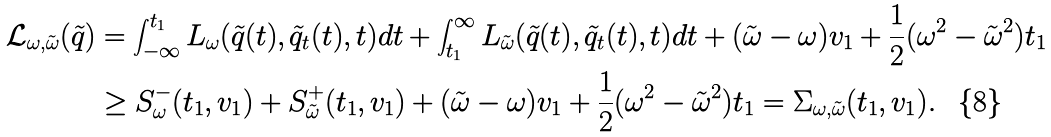<formula> <loc_0><loc_0><loc_500><loc_500>\mathcal { L } _ { \omega , \tilde { \omega } } ( \tilde { q } ) & = \int _ { - \infty } ^ { t _ { 1 } } L _ { \omega } ( \tilde { q } ( t ) , \tilde { q } _ { t } ( t ) , t ) d t + \int _ { t _ { 1 } } ^ { \infty } L _ { \tilde { \omega } } ( \tilde { q } ( t ) , \tilde { q } _ { t } ( t ) , t ) d t + ( \tilde { \omega } - \omega ) v _ { 1 } + \frac { 1 } { 2 } ( \omega ^ { 2 } - \tilde { \omega } ^ { 2 } ) t _ { 1 } \\ & \geq S _ { \omega } ^ { - } ( t _ { 1 } , v _ { 1 } ) + S _ { \tilde { \omega } } ^ { + } ( t _ { 1 } , v _ { 1 } ) + ( \tilde { \omega } - \omega ) v _ { 1 } + \frac { 1 } { 2 } ( \omega ^ { 2 } - \tilde { \omega } ^ { 2 } ) t _ { 1 } = \Sigma _ { \omega , \tilde { \omega } } ( t _ { 1 } , v _ { 1 } ) .</formula> 